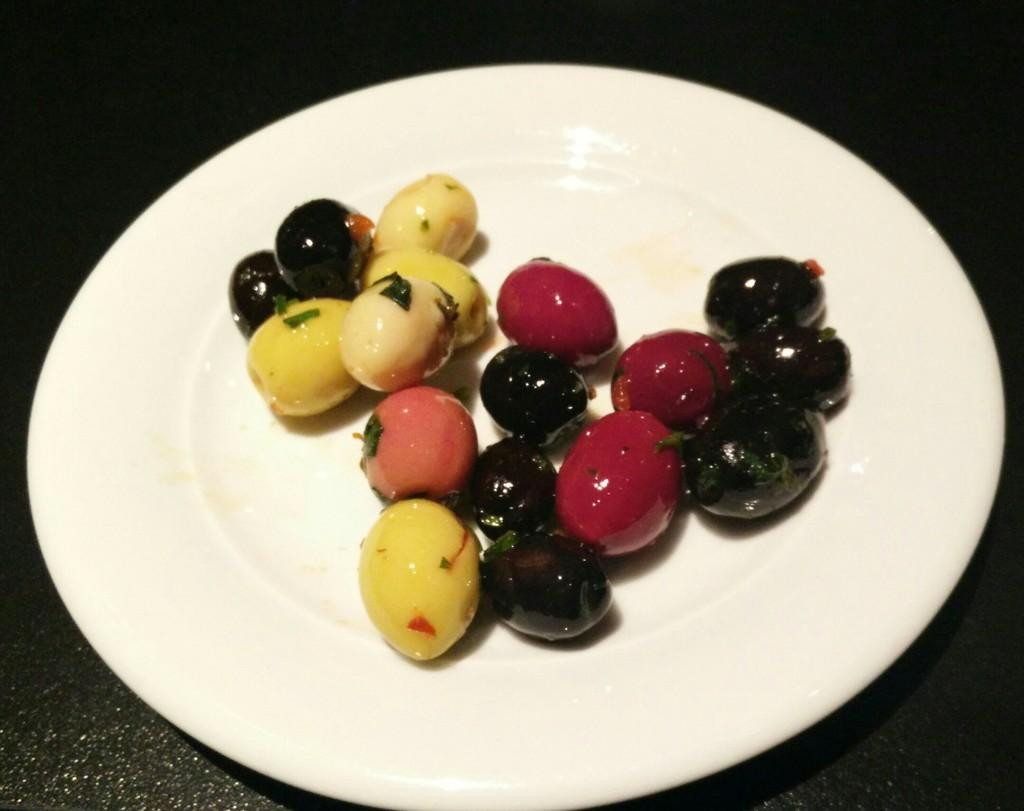What type of food can be seen in the image? There are fruits in the image. How can the fruits be distinguished from one another? The fruits are in different colors. What is the color of the plate on which the fruits are placed? The fruits are on a white color plate. What color is the background of the image? The background of the image is black. How many children are playing with the pigs in the image? There are no children or pigs present in the image; it features fruits on a plate with a black background. 